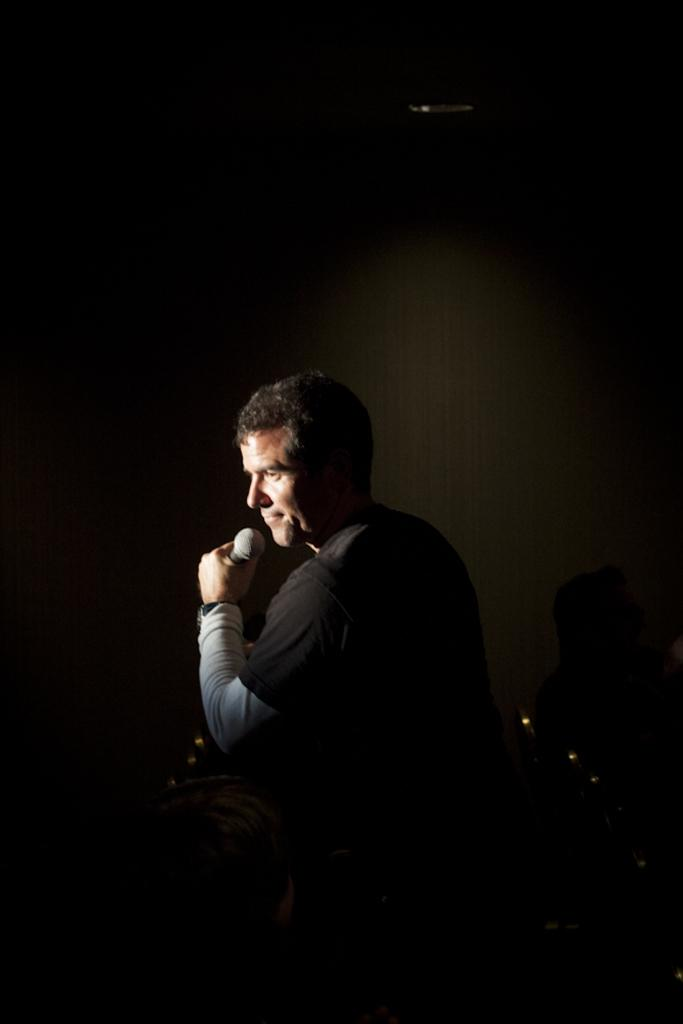Who or what is the main subject in the image? There is a person in the image. What is the person wearing? The person is wearing a black T-shirt. What is the person holding in the image? The person is holding a mic. What type of trail can be seen behind the person in the image? There is no trail visible in the image; it only features a person wearing a black T-shirt and holding a mic. 